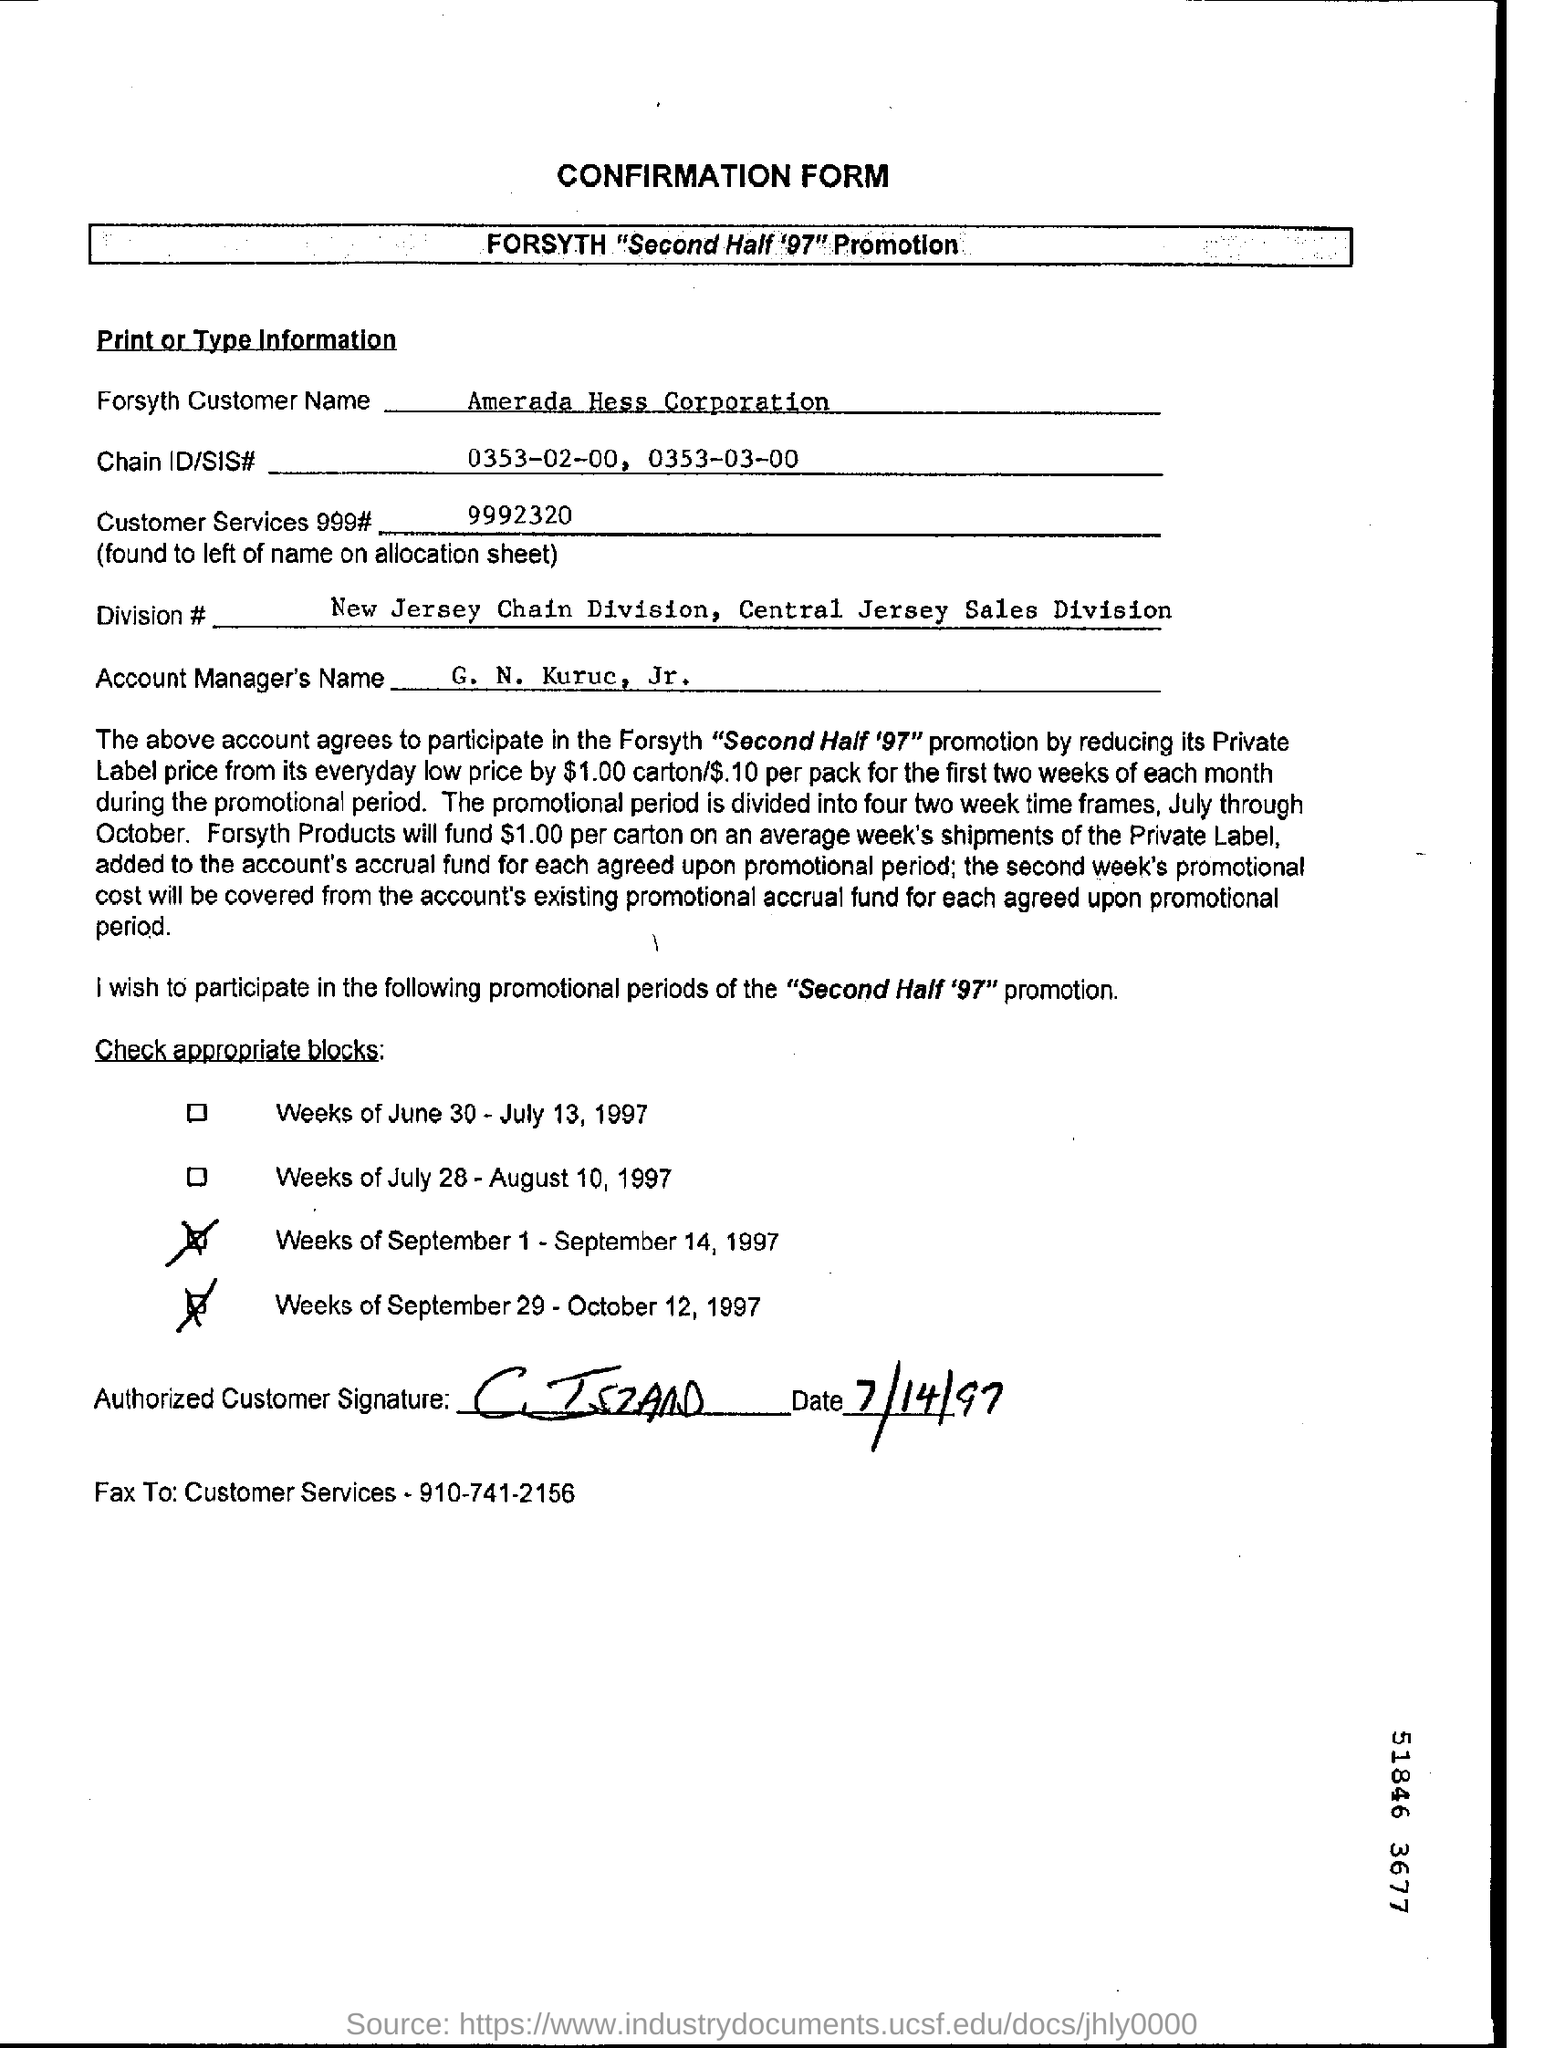What is the Forsyth Customer Name?
Keep it short and to the point. Amerada Hess Corporation. What is the Customer Services 999# ?
Offer a very short reply. 9992320. What is the Account Manager's Name?
Provide a short and direct response. G. N. kuruc, jr. What is the Chain ID/SIS # ?
Offer a terse response. 0353-02-00, 0353-03-00. 